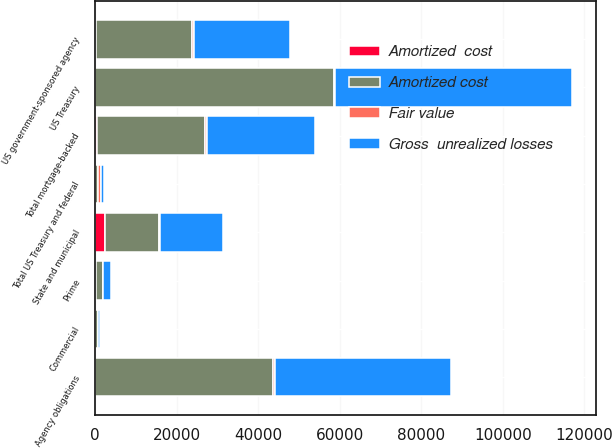<chart> <loc_0><loc_0><loc_500><loc_500><stacked_bar_chart><ecel><fcel>US government-sponsored agency<fcel>Prime<fcel>Commercial<fcel>Total mortgage-backed<fcel>US Treasury<fcel>Agency obligations<fcel>Total US Treasury and federal<fcel>State and municipal<nl><fcel>Gross  unrealized losses<fcel>23433<fcel>1985<fcel>592<fcel>26490<fcel>58069<fcel>43294<fcel>583<fcel>15660<nl><fcel>Fair value<fcel>425<fcel>18<fcel>21<fcel>468<fcel>435<fcel>375<fcel>810<fcel>75<nl><fcel>Amortized  cost<fcel>235<fcel>177<fcel>39<fcel>452<fcel>56<fcel>55<fcel>111<fcel>2500<nl><fcel>Amortized cost<fcel>23623<fcel>1826<fcel>574<fcel>26506<fcel>58448<fcel>43614<fcel>583<fcel>13235<nl></chart> 